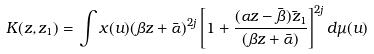Convert formula to latex. <formula><loc_0><loc_0><loc_500><loc_500>K ( z , z _ { 1 } ) = \int x ( u ) ( \beta z + \bar { \alpha } ) ^ { 2 j } \left [ 1 + \frac { ( \alpha z - \bar { \beta } ) \bar { z } _ { 1 } } { ( \beta z + \bar { \alpha } ) } \right ] ^ { 2 j } d \mu ( u )</formula> 